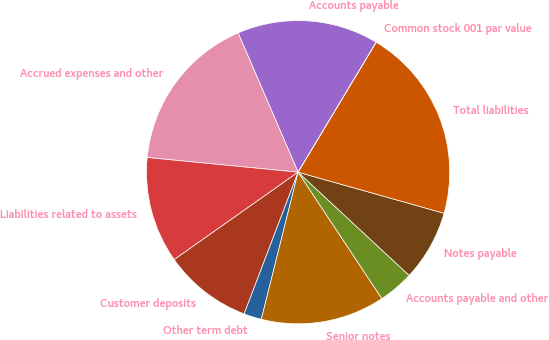Convert chart to OTSL. <chart><loc_0><loc_0><loc_500><loc_500><pie_chart><fcel>Accounts payable<fcel>Accrued expenses and other<fcel>Liabilities related to assets<fcel>Customer deposits<fcel>Other term debt<fcel>Senior notes<fcel>Accounts payable and other<fcel>Notes payable<fcel>Total liabilities<fcel>Common stock 001 par value<nl><fcel>15.09%<fcel>16.98%<fcel>11.32%<fcel>9.43%<fcel>1.89%<fcel>13.21%<fcel>3.77%<fcel>7.55%<fcel>20.75%<fcel>0.0%<nl></chart> 